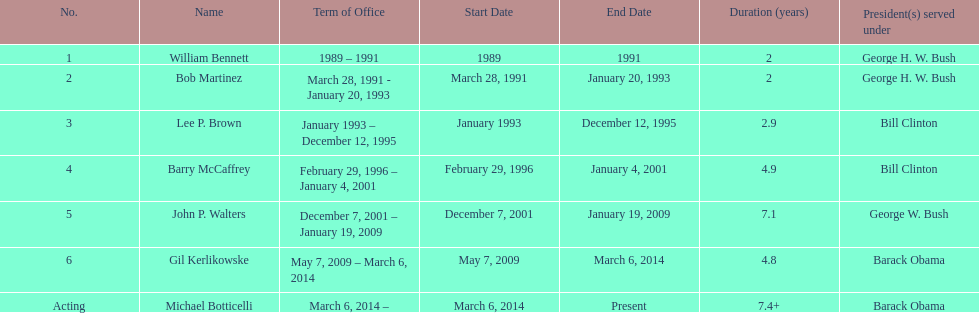Give me the full table as a dictionary. {'header': ['No.', 'Name', 'Term of Office', 'Start Date', 'End Date', 'Duration (years)', 'President(s) served under'], 'rows': [['1', 'William Bennett', '1989 – 1991', '1989', '1991', '2', 'George H. W. Bush'], ['2', 'Bob Martinez', 'March 28, 1991 - January 20, 1993', 'March 28, 1991', 'January 20, 1993', '2', 'George H. W. Bush'], ['3', 'Lee P. Brown', 'January 1993 – December 12, 1995', 'January 1993', 'December 12, 1995', '2.9', 'Bill Clinton'], ['4', 'Barry McCaffrey', 'February 29, 1996 – January 4, 2001', 'February 29, 1996', 'January 4, 2001', '4.9', 'Bill Clinton'], ['5', 'John P. Walters', 'December 7, 2001 – January 19, 2009', 'December 7, 2001', 'January 19, 2009', '7.1', 'George W. Bush'], ['6', 'Gil Kerlikowske', 'May 7, 2009 – March 6, 2014', 'May 7, 2009', 'March 6, 2014', '4.8', 'Barack Obama'], ['Acting', 'Michael Botticelli', 'March 6, 2014 –', 'March 6, 2014', 'Present', '7.4+', 'Barack Obama']]} How long did lee p. brown serve for? 2 years. 